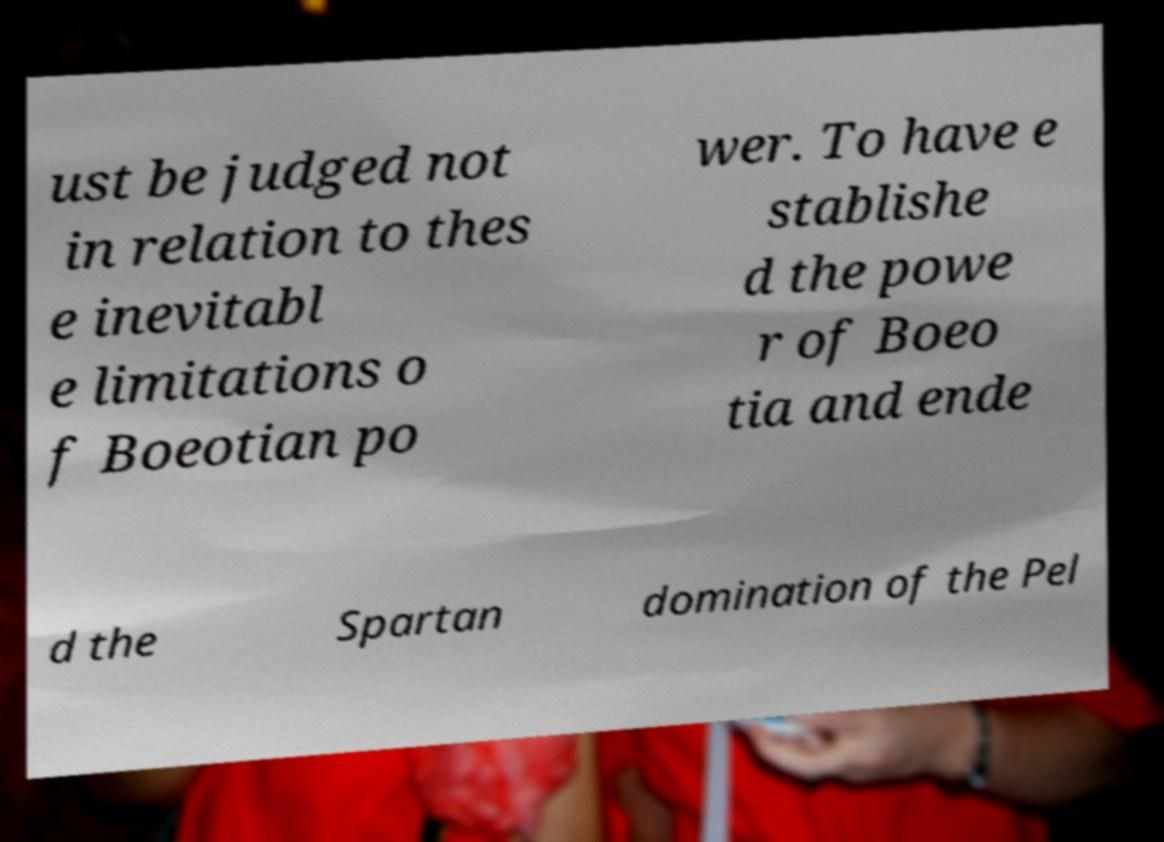Please read and relay the text visible in this image. What does it say? ust be judged not in relation to thes e inevitabl e limitations o f Boeotian po wer. To have e stablishe d the powe r of Boeo tia and ende d the Spartan domination of the Pel 